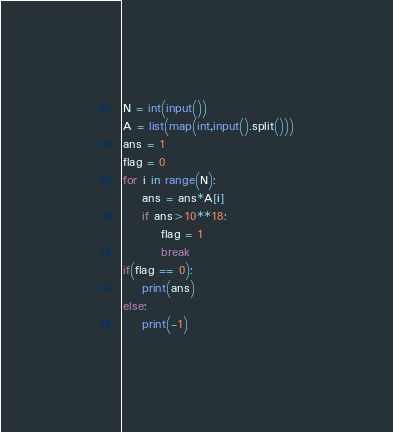<code> <loc_0><loc_0><loc_500><loc_500><_Python_>N = int(input())
A = list(map(int,input().split()))
ans = 1
flag = 0
for i in range(N):
    ans = ans*A[i]
    if ans>10**18:
        flag = 1
        break
if(flag == 0):
    print(ans)
else:
    print(-1)
</code> 